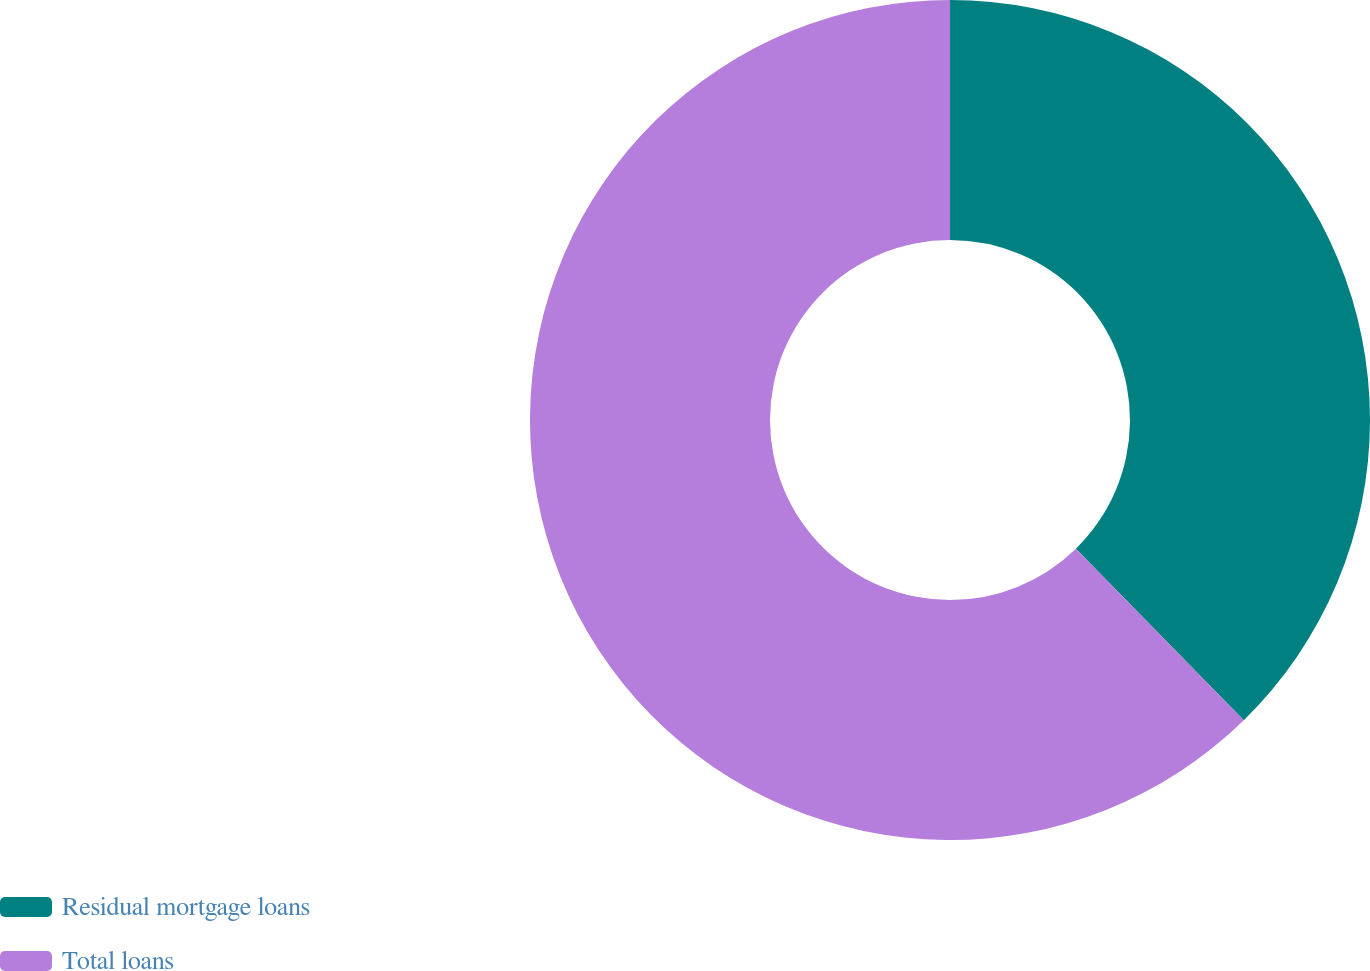<chart> <loc_0><loc_0><loc_500><loc_500><pie_chart><fcel>Residual mortgage loans<fcel>Total loans<nl><fcel>37.67%<fcel>62.33%<nl></chart> 